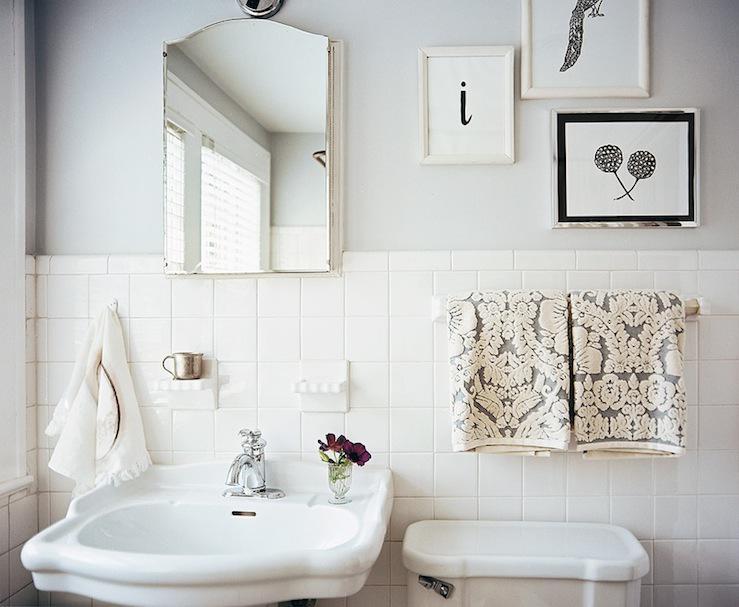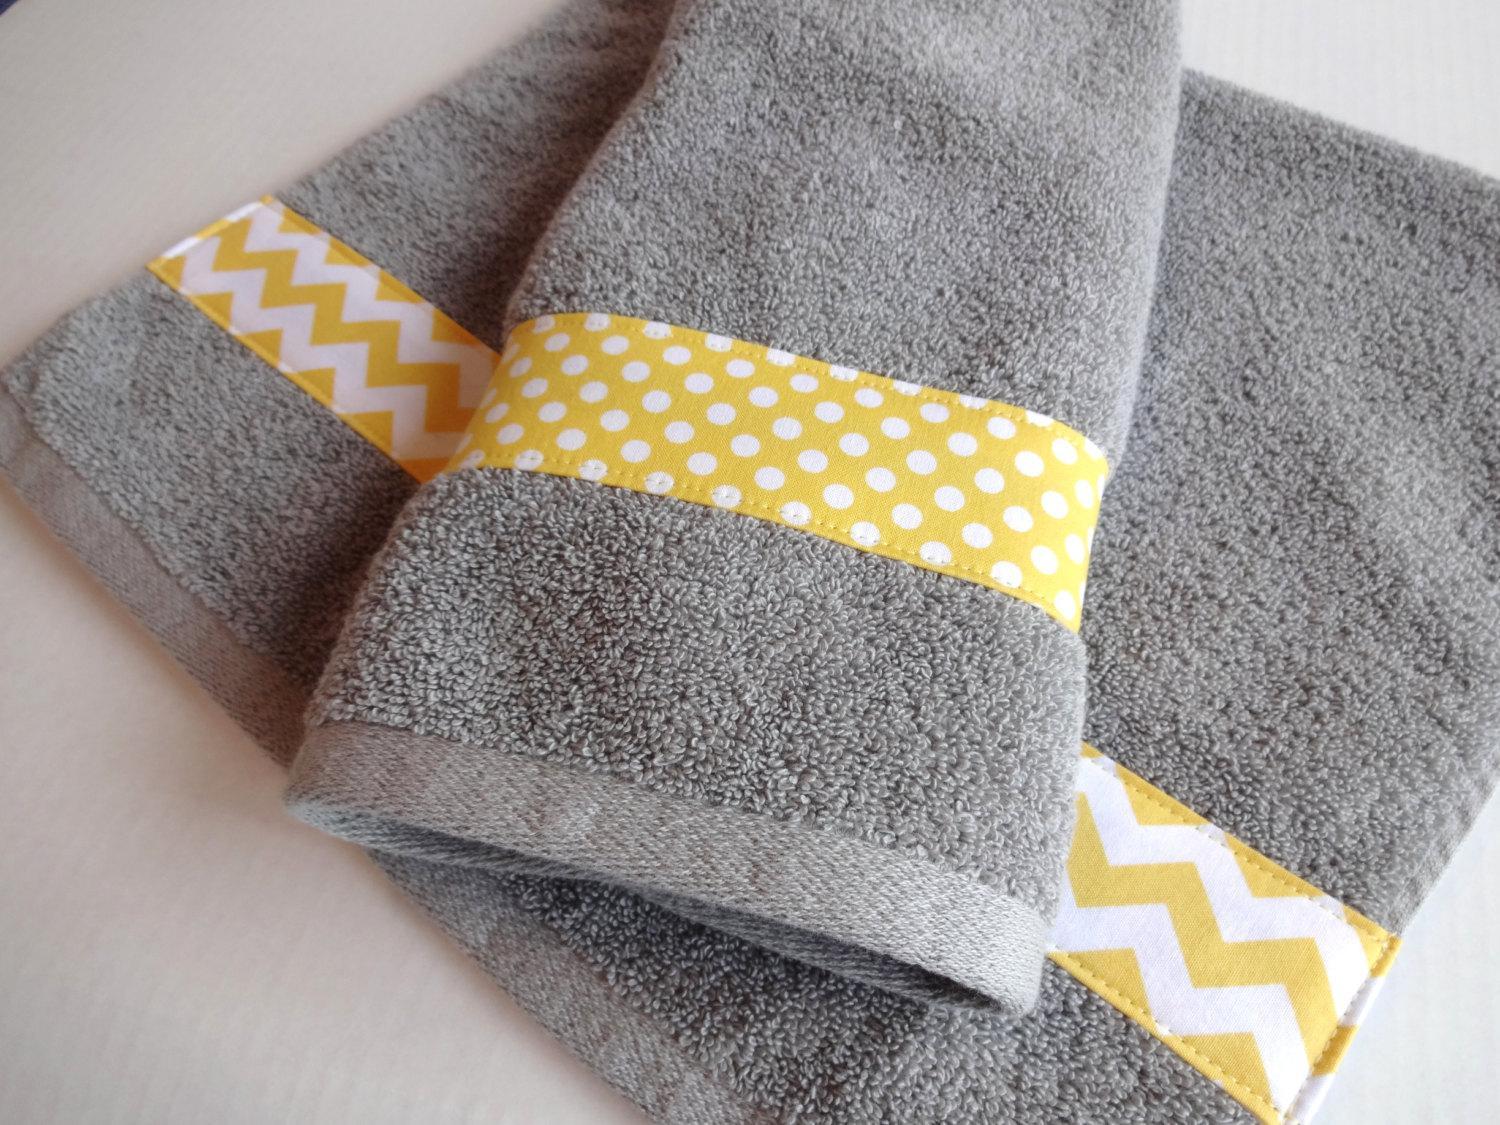The first image is the image on the left, the second image is the image on the right. Assess this claim about the two images: "In one image, two towels hang side by side on one bar.". Correct or not? Answer yes or no. Yes. The first image is the image on the left, the second image is the image on the right. For the images displayed, is the sentence "A wall mounted bathroom sink is in one image." factually correct? Answer yes or no. Yes. 